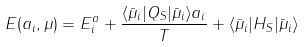Convert formula to latex. <formula><loc_0><loc_0><loc_500><loc_500>E ( a _ { i } , \mu ) = E _ { i } ^ { a } + \frac { \langle { \bar { \mu } } _ { i } | Q _ { S } | { \bar { \mu } } _ { i } \rangle a _ { i } } { T } + \langle { \bar { \mu } } _ { i } | H _ { S } | { \bar { \mu } } _ { i } \rangle</formula> 